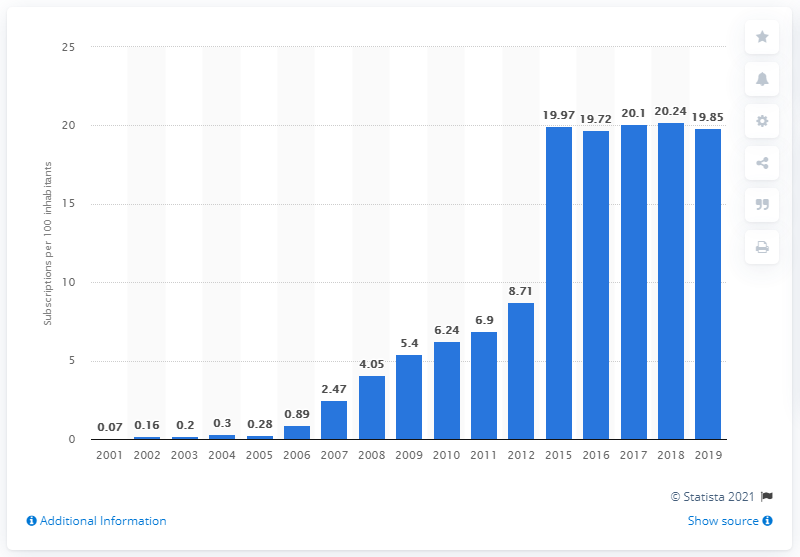Mention a couple of crucial points in this snapshot. In 2019, there were 19.85 fixed broadband subscriptions for every 100 inhabitants in Saudi Arabia, according to the most recent data available. 